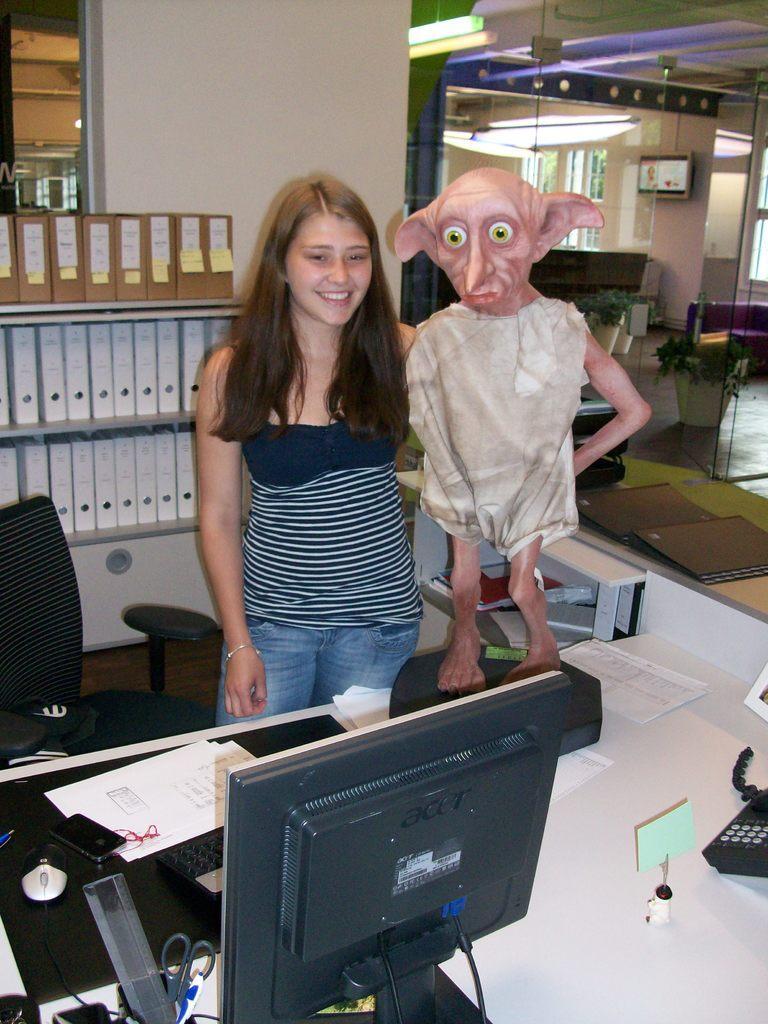Can you describe this image briefly? In this image I can see a girl is standing. Here on this table I can see a monitor, a telephone and few papers. 